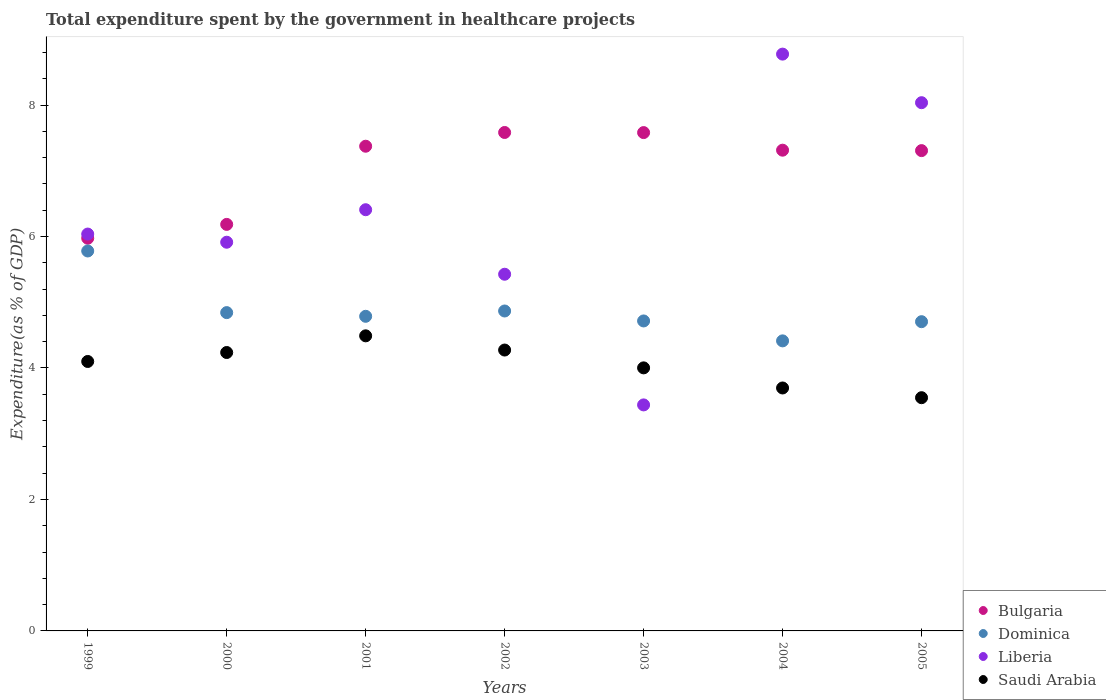How many different coloured dotlines are there?
Your response must be concise. 4. Is the number of dotlines equal to the number of legend labels?
Offer a terse response. Yes. What is the total expenditure spent by the government in healthcare projects in Bulgaria in 2004?
Your answer should be very brief. 7.31. Across all years, what is the maximum total expenditure spent by the government in healthcare projects in Dominica?
Give a very brief answer. 5.78. Across all years, what is the minimum total expenditure spent by the government in healthcare projects in Dominica?
Your response must be concise. 4.41. In which year was the total expenditure spent by the government in healthcare projects in Dominica maximum?
Offer a very short reply. 1999. In which year was the total expenditure spent by the government in healthcare projects in Liberia minimum?
Offer a terse response. 2003. What is the total total expenditure spent by the government in healthcare projects in Saudi Arabia in the graph?
Provide a succinct answer. 28.34. What is the difference between the total expenditure spent by the government in healthcare projects in Saudi Arabia in 2000 and that in 2005?
Give a very brief answer. 0.69. What is the difference between the total expenditure spent by the government in healthcare projects in Dominica in 2003 and the total expenditure spent by the government in healthcare projects in Bulgaria in 2005?
Provide a succinct answer. -2.59. What is the average total expenditure spent by the government in healthcare projects in Dominica per year?
Give a very brief answer. 4.87. In the year 2003, what is the difference between the total expenditure spent by the government in healthcare projects in Saudi Arabia and total expenditure spent by the government in healthcare projects in Dominica?
Your answer should be compact. -0.71. In how many years, is the total expenditure spent by the government in healthcare projects in Bulgaria greater than 1.2000000000000002 %?
Keep it short and to the point. 7. What is the ratio of the total expenditure spent by the government in healthcare projects in Liberia in 2000 to that in 2004?
Give a very brief answer. 0.67. Is the total expenditure spent by the government in healthcare projects in Dominica in 2001 less than that in 2004?
Provide a succinct answer. No. Is the difference between the total expenditure spent by the government in healthcare projects in Saudi Arabia in 1999 and 2003 greater than the difference between the total expenditure spent by the government in healthcare projects in Dominica in 1999 and 2003?
Give a very brief answer. No. What is the difference between the highest and the second highest total expenditure spent by the government in healthcare projects in Bulgaria?
Your response must be concise. 0. What is the difference between the highest and the lowest total expenditure spent by the government in healthcare projects in Liberia?
Your answer should be compact. 5.34. Is the sum of the total expenditure spent by the government in healthcare projects in Bulgaria in 2000 and 2005 greater than the maximum total expenditure spent by the government in healthcare projects in Dominica across all years?
Provide a short and direct response. Yes. Is it the case that in every year, the sum of the total expenditure spent by the government in healthcare projects in Saudi Arabia and total expenditure spent by the government in healthcare projects in Liberia  is greater than the sum of total expenditure spent by the government in healthcare projects in Bulgaria and total expenditure spent by the government in healthcare projects in Dominica?
Your response must be concise. No. Is it the case that in every year, the sum of the total expenditure spent by the government in healthcare projects in Liberia and total expenditure spent by the government in healthcare projects in Saudi Arabia  is greater than the total expenditure spent by the government in healthcare projects in Dominica?
Your answer should be very brief. Yes. Is the total expenditure spent by the government in healthcare projects in Saudi Arabia strictly greater than the total expenditure spent by the government in healthcare projects in Bulgaria over the years?
Provide a short and direct response. No. Is the total expenditure spent by the government in healthcare projects in Liberia strictly less than the total expenditure spent by the government in healthcare projects in Dominica over the years?
Offer a terse response. No. How many dotlines are there?
Provide a succinct answer. 4. Are the values on the major ticks of Y-axis written in scientific E-notation?
Your answer should be very brief. No. Does the graph contain any zero values?
Keep it short and to the point. No. Does the graph contain grids?
Offer a very short reply. No. Where does the legend appear in the graph?
Keep it short and to the point. Bottom right. How are the legend labels stacked?
Offer a terse response. Vertical. What is the title of the graph?
Give a very brief answer. Total expenditure spent by the government in healthcare projects. Does "Congo (Democratic)" appear as one of the legend labels in the graph?
Your response must be concise. No. What is the label or title of the Y-axis?
Provide a succinct answer. Expenditure(as % of GDP). What is the Expenditure(as % of GDP) of Bulgaria in 1999?
Provide a short and direct response. 5.97. What is the Expenditure(as % of GDP) of Dominica in 1999?
Provide a short and direct response. 5.78. What is the Expenditure(as % of GDP) of Liberia in 1999?
Provide a succinct answer. 6.04. What is the Expenditure(as % of GDP) in Saudi Arabia in 1999?
Offer a very short reply. 4.1. What is the Expenditure(as % of GDP) in Bulgaria in 2000?
Your answer should be very brief. 6.18. What is the Expenditure(as % of GDP) of Dominica in 2000?
Offer a terse response. 4.84. What is the Expenditure(as % of GDP) in Liberia in 2000?
Your answer should be compact. 5.91. What is the Expenditure(as % of GDP) of Saudi Arabia in 2000?
Your answer should be very brief. 4.24. What is the Expenditure(as % of GDP) in Bulgaria in 2001?
Your answer should be very brief. 7.37. What is the Expenditure(as % of GDP) in Dominica in 2001?
Give a very brief answer. 4.79. What is the Expenditure(as % of GDP) in Liberia in 2001?
Provide a short and direct response. 6.41. What is the Expenditure(as % of GDP) of Saudi Arabia in 2001?
Provide a succinct answer. 4.49. What is the Expenditure(as % of GDP) in Bulgaria in 2002?
Your response must be concise. 7.58. What is the Expenditure(as % of GDP) in Dominica in 2002?
Make the answer very short. 4.87. What is the Expenditure(as % of GDP) in Liberia in 2002?
Offer a terse response. 5.43. What is the Expenditure(as % of GDP) in Saudi Arabia in 2002?
Offer a very short reply. 4.27. What is the Expenditure(as % of GDP) in Bulgaria in 2003?
Provide a short and direct response. 7.58. What is the Expenditure(as % of GDP) in Dominica in 2003?
Your answer should be very brief. 4.72. What is the Expenditure(as % of GDP) in Liberia in 2003?
Give a very brief answer. 3.44. What is the Expenditure(as % of GDP) of Saudi Arabia in 2003?
Provide a succinct answer. 4. What is the Expenditure(as % of GDP) of Bulgaria in 2004?
Provide a short and direct response. 7.31. What is the Expenditure(as % of GDP) in Dominica in 2004?
Offer a terse response. 4.41. What is the Expenditure(as % of GDP) of Liberia in 2004?
Offer a very short reply. 8.77. What is the Expenditure(as % of GDP) in Saudi Arabia in 2004?
Provide a short and direct response. 3.7. What is the Expenditure(as % of GDP) in Bulgaria in 2005?
Offer a very short reply. 7.31. What is the Expenditure(as % of GDP) of Dominica in 2005?
Your answer should be compact. 4.7. What is the Expenditure(as % of GDP) in Liberia in 2005?
Your response must be concise. 8.04. What is the Expenditure(as % of GDP) in Saudi Arabia in 2005?
Provide a short and direct response. 3.55. Across all years, what is the maximum Expenditure(as % of GDP) in Bulgaria?
Ensure brevity in your answer.  7.58. Across all years, what is the maximum Expenditure(as % of GDP) of Dominica?
Provide a short and direct response. 5.78. Across all years, what is the maximum Expenditure(as % of GDP) of Liberia?
Your response must be concise. 8.77. Across all years, what is the maximum Expenditure(as % of GDP) in Saudi Arabia?
Offer a terse response. 4.49. Across all years, what is the minimum Expenditure(as % of GDP) of Bulgaria?
Offer a very short reply. 5.97. Across all years, what is the minimum Expenditure(as % of GDP) in Dominica?
Your answer should be very brief. 4.41. Across all years, what is the minimum Expenditure(as % of GDP) in Liberia?
Provide a short and direct response. 3.44. Across all years, what is the minimum Expenditure(as % of GDP) of Saudi Arabia?
Make the answer very short. 3.55. What is the total Expenditure(as % of GDP) of Bulgaria in the graph?
Give a very brief answer. 49.32. What is the total Expenditure(as % of GDP) of Dominica in the graph?
Offer a terse response. 34.11. What is the total Expenditure(as % of GDP) in Liberia in the graph?
Your answer should be very brief. 44.03. What is the total Expenditure(as % of GDP) of Saudi Arabia in the graph?
Keep it short and to the point. 28.34. What is the difference between the Expenditure(as % of GDP) in Bulgaria in 1999 and that in 2000?
Give a very brief answer. -0.21. What is the difference between the Expenditure(as % of GDP) of Dominica in 1999 and that in 2000?
Offer a terse response. 0.94. What is the difference between the Expenditure(as % of GDP) in Liberia in 1999 and that in 2000?
Your response must be concise. 0.12. What is the difference between the Expenditure(as % of GDP) of Saudi Arabia in 1999 and that in 2000?
Provide a short and direct response. -0.14. What is the difference between the Expenditure(as % of GDP) of Bulgaria in 1999 and that in 2001?
Give a very brief answer. -1.4. What is the difference between the Expenditure(as % of GDP) in Liberia in 1999 and that in 2001?
Offer a terse response. -0.37. What is the difference between the Expenditure(as % of GDP) in Saudi Arabia in 1999 and that in 2001?
Provide a short and direct response. -0.39. What is the difference between the Expenditure(as % of GDP) in Bulgaria in 1999 and that in 2002?
Offer a very short reply. -1.61. What is the difference between the Expenditure(as % of GDP) of Dominica in 1999 and that in 2002?
Give a very brief answer. 0.91. What is the difference between the Expenditure(as % of GDP) in Liberia in 1999 and that in 2002?
Offer a very short reply. 0.61. What is the difference between the Expenditure(as % of GDP) of Saudi Arabia in 1999 and that in 2002?
Give a very brief answer. -0.17. What is the difference between the Expenditure(as % of GDP) in Bulgaria in 1999 and that in 2003?
Offer a terse response. -1.61. What is the difference between the Expenditure(as % of GDP) of Dominica in 1999 and that in 2003?
Your response must be concise. 1.06. What is the difference between the Expenditure(as % of GDP) of Liberia in 1999 and that in 2003?
Offer a terse response. 2.6. What is the difference between the Expenditure(as % of GDP) in Saudi Arabia in 1999 and that in 2003?
Your answer should be compact. 0.1. What is the difference between the Expenditure(as % of GDP) of Bulgaria in 1999 and that in 2004?
Your answer should be very brief. -1.34. What is the difference between the Expenditure(as % of GDP) of Dominica in 1999 and that in 2004?
Your answer should be compact. 1.37. What is the difference between the Expenditure(as % of GDP) of Liberia in 1999 and that in 2004?
Give a very brief answer. -2.74. What is the difference between the Expenditure(as % of GDP) of Saudi Arabia in 1999 and that in 2004?
Make the answer very short. 0.4. What is the difference between the Expenditure(as % of GDP) of Bulgaria in 1999 and that in 2005?
Ensure brevity in your answer.  -1.33. What is the difference between the Expenditure(as % of GDP) in Dominica in 1999 and that in 2005?
Provide a short and direct response. 1.08. What is the difference between the Expenditure(as % of GDP) in Liberia in 1999 and that in 2005?
Keep it short and to the point. -2. What is the difference between the Expenditure(as % of GDP) of Saudi Arabia in 1999 and that in 2005?
Your response must be concise. 0.55. What is the difference between the Expenditure(as % of GDP) in Bulgaria in 2000 and that in 2001?
Ensure brevity in your answer.  -1.19. What is the difference between the Expenditure(as % of GDP) in Dominica in 2000 and that in 2001?
Provide a short and direct response. 0.06. What is the difference between the Expenditure(as % of GDP) in Liberia in 2000 and that in 2001?
Provide a short and direct response. -0.49. What is the difference between the Expenditure(as % of GDP) in Saudi Arabia in 2000 and that in 2001?
Give a very brief answer. -0.25. What is the difference between the Expenditure(as % of GDP) in Bulgaria in 2000 and that in 2002?
Offer a terse response. -1.4. What is the difference between the Expenditure(as % of GDP) in Dominica in 2000 and that in 2002?
Offer a terse response. -0.02. What is the difference between the Expenditure(as % of GDP) of Liberia in 2000 and that in 2002?
Offer a very short reply. 0.49. What is the difference between the Expenditure(as % of GDP) in Saudi Arabia in 2000 and that in 2002?
Your response must be concise. -0.04. What is the difference between the Expenditure(as % of GDP) in Bulgaria in 2000 and that in 2003?
Your answer should be compact. -1.4. What is the difference between the Expenditure(as % of GDP) of Dominica in 2000 and that in 2003?
Keep it short and to the point. 0.13. What is the difference between the Expenditure(as % of GDP) of Liberia in 2000 and that in 2003?
Your answer should be very brief. 2.47. What is the difference between the Expenditure(as % of GDP) in Saudi Arabia in 2000 and that in 2003?
Give a very brief answer. 0.23. What is the difference between the Expenditure(as % of GDP) in Bulgaria in 2000 and that in 2004?
Give a very brief answer. -1.13. What is the difference between the Expenditure(as % of GDP) in Dominica in 2000 and that in 2004?
Your answer should be very brief. 0.43. What is the difference between the Expenditure(as % of GDP) of Liberia in 2000 and that in 2004?
Make the answer very short. -2.86. What is the difference between the Expenditure(as % of GDP) in Saudi Arabia in 2000 and that in 2004?
Give a very brief answer. 0.54. What is the difference between the Expenditure(as % of GDP) of Bulgaria in 2000 and that in 2005?
Provide a succinct answer. -1.12. What is the difference between the Expenditure(as % of GDP) in Dominica in 2000 and that in 2005?
Your answer should be very brief. 0.14. What is the difference between the Expenditure(as % of GDP) in Liberia in 2000 and that in 2005?
Your response must be concise. -2.12. What is the difference between the Expenditure(as % of GDP) of Saudi Arabia in 2000 and that in 2005?
Offer a terse response. 0.69. What is the difference between the Expenditure(as % of GDP) in Bulgaria in 2001 and that in 2002?
Make the answer very short. -0.21. What is the difference between the Expenditure(as % of GDP) in Dominica in 2001 and that in 2002?
Give a very brief answer. -0.08. What is the difference between the Expenditure(as % of GDP) of Liberia in 2001 and that in 2002?
Your response must be concise. 0.98. What is the difference between the Expenditure(as % of GDP) in Saudi Arabia in 2001 and that in 2002?
Your response must be concise. 0.22. What is the difference between the Expenditure(as % of GDP) in Bulgaria in 2001 and that in 2003?
Your response must be concise. -0.21. What is the difference between the Expenditure(as % of GDP) of Dominica in 2001 and that in 2003?
Offer a very short reply. 0.07. What is the difference between the Expenditure(as % of GDP) of Liberia in 2001 and that in 2003?
Provide a short and direct response. 2.97. What is the difference between the Expenditure(as % of GDP) in Saudi Arabia in 2001 and that in 2003?
Offer a terse response. 0.49. What is the difference between the Expenditure(as % of GDP) in Bulgaria in 2001 and that in 2004?
Keep it short and to the point. 0.06. What is the difference between the Expenditure(as % of GDP) in Dominica in 2001 and that in 2004?
Offer a very short reply. 0.37. What is the difference between the Expenditure(as % of GDP) in Liberia in 2001 and that in 2004?
Your answer should be compact. -2.37. What is the difference between the Expenditure(as % of GDP) in Saudi Arabia in 2001 and that in 2004?
Offer a very short reply. 0.79. What is the difference between the Expenditure(as % of GDP) of Bulgaria in 2001 and that in 2005?
Make the answer very short. 0.07. What is the difference between the Expenditure(as % of GDP) in Dominica in 2001 and that in 2005?
Make the answer very short. 0.08. What is the difference between the Expenditure(as % of GDP) in Liberia in 2001 and that in 2005?
Provide a short and direct response. -1.63. What is the difference between the Expenditure(as % of GDP) in Saudi Arabia in 2001 and that in 2005?
Your response must be concise. 0.94. What is the difference between the Expenditure(as % of GDP) in Bulgaria in 2002 and that in 2003?
Give a very brief answer. 0. What is the difference between the Expenditure(as % of GDP) of Dominica in 2002 and that in 2003?
Provide a short and direct response. 0.15. What is the difference between the Expenditure(as % of GDP) of Liberia in 2002 and that in 2003?
Offer a terse response. 1.99. What is the difference between the Expenditure(as % of GDP) in Saudi Arabia in 2002 and that in 2003?
Your response must be concise. 0.27. What is the difference between the Expenditure(as % of GDP) in Bulgaria in 2002 and that in 2004?
Your response must be concise. 0.27. What is the difference between the Expenditure(as % of GDP) in Dominica in 2002 and that in 2004?
Your answer should be compact. 0.45. What is the difference between the Expenditure(as % of GDP) in Liberia in 2002 and that in 2004?
Provide a short and direct response. -3.35. What is the difference between the Expenditure(as % of GDP) in Saudi Arabia in 2002 and that in 2004?
Your answer should be very brief. 0.58. What is the difference between the Expenditure(as % of GDP) of Bulgaria in 2002 and that in 2005?
Provide a succinct answer. 0.28. What is the difference between the Expenditure(as % of GDP) of Dominica in 2002 and that in 2005?
Ensure brevity in your answer.  0.16. What is the difference between the Expenditure(as % of GDP) of Liberia in 2002 and that in 2005?
Provide a short and direct response. -2.61. What is the difference between the Expenditure(as % of GDP) in Saudi Arabia in 2002 and that in 2005?
Offer a terse response. 0.72. What is the difference between the Expenditure(as % of GDP) of Bulgaria in 2003 and that in 2004?
Keep it short and to the point. 0.27. What is the difference between the Expenditure(as % of GDP) in Dominica in 2003 and that in 2004?
Your response must be concise. 0.3. What is the difference between the Expenditure(as % of GDP) in Liberia in 2003 and that in 2004?
Offer a terse response. -5.34. What is the difference between the Expenditure(as % of GDP) in Saudi Arabia in 2003 and that in 2004?
Provide a short and direct response. 0.31. What is the difference between the Expenditure(as % of GDP) of Bulgaria in 2003 and that in 2005?
Your answer should be very brief. 0.27. What is the difference between the Expenditure(as % of GDP) in Dominica in 2003 and that in 2005?
Keep it short and to the point. 0.01. What is the difference between the Expenditure(as % of GDP) in Liberia in 2003 and that in 2005?
Provide a short and direct response. -4.6. What is the difference between the Expenditure(as % of GDP) of Saudi Arabia in 2003 and that in 2005?
Give a very brief answer. 0.45. What is the difference between the Expenditure(as % of GDP) of Bulgaria in 2004 and that in 2005?
Keep it short and to the point. 0.01. What is the difference between the Expenditure(as % of GDP) of Dominica in 2004 and that in 2005?
Your answer should be very brief. -0.29. What is the difference between the Expenditure(as % of GDP) in Liberia in 2004 and that in 2005?
Make the answer very short. 0.74. What is the difference between the Expenditure(as % of GDP) of Saudi Arabia in 2004 and that in 2005?
Ensure brevity in your answer.  0.15. What is the difference between the Expenditure(as % of GDP) of Bulgaria in 1999 and the Expenditure(as % of GDP) of Dominica in 2000?
Offer a terse response. 1.13. What is the difference between the Expenditure(as % of GDP) of Bulgaria in 1999 and the Expenditure(as % of GDP) of Liberia in 2000?
Your response must be concise. 0.06. What is the difference between the Expenditure(as % of GDP) of Bulgaria in 1999 and the Expenditure(as % of GDP) of Saudi Arabia in 2000?
Ensure brevity in your answer.  1.74. What is the difference between the Expenditure(as % of GDP) in Dominica in 1999 and the Expenditure(as % of GDP) in Liberia in 2000?
Offer a very short reply. -0.13. What is the difference between the Expenditure(as % of GDP) of Dominica in 1999 and the Expenditure(as % of GDP) of Saudi Arabia in 2000?
Make the answer very short. 1.54. What is the difference between the Expenditure(as % of GDP) of Liberia in 1999 and the Expenditure(as % of GDP) of Saudi Arabia in 2000?
Ensure brevity in your answer.  1.8. What is the difference between the Expenditure(as % of GDP) of Bulgaria in 1999 and the Expenditure(as % of GDP) of Dominica in 2001?
Make the answer very short. 1.19. What is the difference between the Expenditure(as % of GDP) of Bulgaria in 1999 and the Expenditure(as % of GDP) of Liberia in 2001?
Provide a short and direct response. -0.43. What is the difference between the Expenditure(as % of GDP) of Bulgaria in 1999 and the Expenditure(as % of GDP) of Saudi Arabia in 2001?
Give a very brief answer. 1.48. What is the difference between the Expenditure(as % of GDP) of Dominica in 1999 and the Expenditure(as % of GDP) of Liberia in 2001?
Provide a succinct answer. -0.63. What is the difference between the Expenditure(as % of GDP) of Dominica in 1999 and the Expenditure(as % of GDP) of Saudi Arabia in 2001?
Offer a very short reply. 1.29. What is the difference between the Expenditure(as % of GDP) in Liberia in 1999 and the Expenditure(as % of GDP) in Saudi Arabia in 2001?
Your response must be concise. 1.55. What is the difference between the Expenditure(as % of GDP) in Bulgaria in 1999 and the Expenditure(as % of GDP) in Dominica in 2002?
Your answer should be compact. 1.11. What is the difference between the Expenditure(as % of GDP) of Bulgaria in 1999 and the Expenditure(as % of GDP) of Liberia in 2002?
Provide a succinct answer. 0.55. What is the difference between the Expenditure(as % of GDP) of Bulgaria in 1999 and the Expenditure(as % of GDP) of Saudi Arabia in 2002?
Offer a very short reply. 1.7. What is the difference between the Expenditure(as % of GDP) of Dominica in 1999 and the Expenditure(as % of GDP) of Liberia in 2002?
Offer a terse response. 0.35. What is the difference between the Expenditure(as % of GDP) in Dominica in 1999 and the Expenditure(as % of GDP) in Saudi Arabia in 2002?
Ensure brevity in your answer.  1.51. What is the difference between the Expenditure(as % of GDP) in Liberia in 1999 and the Expenditure(as % of GDP) in Saudi Arabia in 2002?
Make the answer very short. 1.76. What is the difference between the Expenditure(as % of GDP) in Bulgaria in 1999 and the Expenditure(as % of GDP) in Dominica in 2003?
Keep it short and to the point. 1.26. What is the difference between the Expenditure(as % of GDP) in Bulgaria in 1999 and the Expenditure(as % of GDP) in Liberia in 2003?
Provide a succinct answer. 2.54. What is the difference between the Expenditure(as % of GDP) of Bulgaria in 1999 and the Expenditure(as % of GDP) of Saudi Arabia in 2003?
Offer a terse response. 1.97. What is the difference between the Expenditure(as % of GDP) in Dominica in 1999 and the Expenditure(as % of GDP) in Liberia in 2003?
Offer a terse response. 2.34. What is the difference between the Expenditure(as % of GDP) of Dominica in 1999 and the Expenditure(as % of GDP) of Saudi Arabia in 2003?
Ensure brevity in your answer.  1.78. What is the difference between the Expenditure(as % of GDP) of Liberia in 1999 and the Expenditure(as % of GDP) of Saudi Arabia in 2003?
Keep it short and to the point. 2.04. What is the difference between the Expenditure(as % of GDP) in Bulgaria in 1999 and the Expenditure(as % of GDP) in Dominica in 2004?
Offer a very short reply. 1.56. What is the difference between the Expenditure(as % of GDP) in Bulgaria in 1999 and the Expenditure(as % of GDP) in Liberia in 2004?
Your answer should be very brief. -2.8. What is the difference between the Expenditure(as % of GDP) of Bulgaria in 1999 and the Expenditure(as % of GDP) of Saudi Arabia in 2004?
Your response must be concise. 2.28. What is the difference between the Expenditure(as % of GDP) of Dominica in 1999 and the Expenditure(as % of GDP) of Liberia in 2004?
Give a very brief answer. -2.99. What is the difference between the Expenditure(as % of GDP) of Dominica in 1999 and the Expenditure(as % of GDP) of Saudi Arabia in 2004?
Offer a terse response. 2.08. What is the difference between the Expenditure(as % of GDP) in Liberia in 1999 and the Expenditure(as % of GDP) in Saudi Arabia in 2004?
Your answer should be very brief. 2.34. What is the difference between the Expenditure(as % of GDP) of Bulgaria in 1999 and the Expenditure(as % of GDP) of Dominica in 2005?
Provide a short and direct response. 1.27. What is the difference between the Expenditure(as % of GDP) in Bulgaria in 1999 and the Expenditure(as % of GDP) in Liberia in 2005?
Give a very brief answer. -2.06. What is the difference between the Expenditure(as % of GDP) of Bulgaria in 1999 and the Expenditure(as % of GDP) of Saudi Arabia in 2005?
Your answer should be compact. 2.43. What is the difference between the Expenditure(as % of GDP) in Dominica in 1999 and the Expenditure(as % of GDP) in Liberia in 2005?
Your answer should be very brief. -2.26. What is the difference between the Expenditure(as % of GDP) of Dominica in 1999 and the Expenditure(as % of GDP) of Saudi Arabia in 2005?
Provide a short and direct response. 2.23. What is the difference between the Expenditure(as % of GDP) of Liberia in 1999 and the Expenditure(as % of GDP) of Saudi Arabia in 2005?
Your answer should be very brief. 2.49. What is the difference between the Expenditure(as % of GDP) of Bulgaria in 2000 and the Expenditure(as % of GDP) of Dominica in 2001?
Your response must be concise. 1.4. What is the difference between the Expenditure(as % of GDP) of Bulgaria in 2000 and the Expenditure(as % of GDP) of Liberia in 2001?
Your answer should be compact. -0.22. What is the difference between the Expenditure(as % of GDP) of Bulgaria in 2000 and the Expenditure(as % of GDP) of Saudi Arabia in 2001?
Provide a short and direct response. 1.7. What is the difference between the Expenditure(as % of GDP) in Dominica in 2000 and the Expenditure(as % of GDP) in Liberia in 2001?
Offer a very short reply. -1.57. What is the difference between the Expenditure(as % of GDP) in Dominica in 2000 and the Expenditure(as % of GDP) in Saudi Arabia in 2001?
Offer a very short reply. 0.35. What is the difference between the Expenditure(as % of GDP) in Liberia in 2000 and the Expenditure(as % of GDP) in Saudi Arabia in 2001?
Your response must be concise. 1.42. What is the difference between the Expenditure(as % of GDP) in Bulgaria in 2000 and the Expenditure(as % of GDP) in Dominica in 2002?
Your response must be concise. 1.32. What is the difference between the Expenditure(as % of GDP) of Bulgaria in 2000 and the Expenditure(as % of GDP) of Liberia in 2002?
Make the answer very short. 0.76. What is the difference between the Expenditure(as % of GDP) of Bulgaria in 2000 and the Expenditure(as % of GDP) of Saudi Arabia in 2002?
Give a very brief answer. 1.91. What is the difference between the Expenditure(as % of GDP) in Dominica in 2000 and the Expenditure(as % of GDP) in Liberia in 2002?
Give a very brief answer. -0.58. What is the difference between the Expenditure(as % of GDP) of Dominica in 2000 and the Expenditure(as % of GDP) of Saudi Arabia in 2002?
Provide a succinct answer. 0.57. What is the difference between the Expenditure(as % of GDP) in Liberia in 2000 and the Expenditure(as % of GDP) in Saudi Arabia in 2002?
Offer a very short reply. 1.64. What is the difference between the Expenditure(as % of GDP) of Bulgaria in 2000 and the Expenditure(as % of GDP) of Dominica in 2003?
Provide a succinct answer. 1.47. What is the difference between the Expenditure(as % of GDP) of Bulgaria in 2000 and the Expenditure(as % of GDP) of Liberia in 2003?
Provide a succinct answer. 2.75. What is the difference between the Expenditure(as % of GDP) of Bulgaria in 2000 and the Expenditure(as % of GDP) of Saudi Arabia in 2003?
Your answer should be compact. 2.18. What is the difference between the Expenditure(as % of GDP) of Dominica in 2000 and the Expenditure(as % of GDP) of Liberia in 2003?
Keep it short and to the point. 1.4. What is the difference between the Expenditure(as % of GDP) in Dominica in 2000 and the Expenditure(as % of GDP) in Saudi Arabia in 2003?
Your answer should be compact. 0.84. What is the difference between the Expenditure(as % of GDP) in Liberia in 2000 and the Expenditure(as % of GDP) in Saudi Arabia in 2003?
Make the answer very short. 1.91. What is the difference between the Expenditure(as % of GDP) of Bulgaria in 2000 and the Expenditure(as % of GDP) of Dominica in 2004?
Offer a very short reply. 1.77. What is the difference between the Expenditure(as % of GDP) of Bulgaria in 2000 and the Expenditure(as % of GDP) of Liberia in 2004?
Provide a succinct answer. -2.59. What is the difference between the Expenditure(as % of GDP) in Bulgaria in 2000 and the Expenditure(as % of GDP) in Saudi Arabia in 2004?
Offer a very short reply. 2.49. What is the difference between the Expenditure(as % of GDP) of Dominica in 2000 and the Expenditure(as % of GDP) of Liberia in 2004?
Provide a succinct answer. -3.93. What is the difference between the Expenditure(as % of GDP) in Dominica in 2000 and the Expenditure(as % of GDP) in Saudi Arabia in 2004?
Offer a very short reply. 1.15. What is the difference between the Expenditure(as % of GDP) of Liberia in 2000 and the Expenditure(as % of GDP) of Saudi Arabia in 2004?
Offer a terse response. 2.22. What is the difference between the Expenditure(as % of GDP) of Bulgaria in 2000 and the Expenditure(as % of GDP) of Dominica in 2005?
Provide a succinct answer. 1.48. What is the difference between the Expenditure(as % of GDP) in Bulgaria in 2000 and the Expenditure(as % of GDP) in Liberia in 2005?
Provide a succinct answer. -1.85. What is the difference between the Expenditure(as % of GDP) in Bulgaria in 2000 and the Expenditure(as % of GDP) in Saudi Arabia in 2005?
Give a very brief answer. 2.64. What is the difference between the Expenditure(as % of GDP) of Dominica in 2000 and the Expenditure(as % of GDP) of Liberia in 2005?
Provide a short and direct response. -3.19. What is the difference between the Expenditure(as % of GDP) in Dominica in 2000 and the Expenditure(as % of GDP) in Saudi Arabia in 2005?
Offer a terse response. 1.29. What is the difference between the Expenditure(as % of GDP) of Liberia in 2000 and the Expenditure(as % of GDP) of Saudi Arabia in 2005?
Your answer should be compact. 2.37. What is the difference between the Expenditure(as % of GDP) in Bulgaria in 2001 and the Expenditure(as % of GDP) in Dominica in 2002?
Your response must be concise. 2.51. What is the difference between the Expenditure(as % of GDP) of Bulgaria in 2001 and the Expenditure(as % of GDP) of Liberia in 2002?
Offer a terse response. 1.95. What is the difference between the Expenditure(as % of GDP) of Bulgaria in 2001 and the Expenditure(as % of GDP) of Saudi Arabia in 2002?
Offer a terse response. 3.1. What is the difference between the Expenditure(as % of GDP) in Dominica in 2001 and the Expenditure(as % of GDP) in Liberia in 2002?
Provide a succinct answer. -0.64. What is the difference between the Expenditure(as % of GDP) in Dominica in 2001 and the Expenditure(as % of GDP) in Saudi Arabia in 2002?
Give a very brief answer. 0.51. What is the difference between the Expenditure(as % of GDP) of Liberia in 2001 and the Expenditure(as % of GDP) of Saudi Arabia in 2002?
Your response must be concise. 2.13. What is the difference between the Expenditure(as % of GDP) in Bulgaria in 2001 and the Expenditure(as % of GDP) in Dominica in 2003?
Your response must be concise. 2.66. What is the difference between the Expenditure(as % of GDP) of Bulgaria in 2001 and the Expenditure(as % of GDP) of Liberia in 2003?
Keep it short and to the point. 3.94. What is the difference between the Expenditure(as % of GDP) of Bulgaria in 2001 and the Expenditure(as % of GDP) of Saudi Arabia in 2003?
Offer a terse response. 3.37. What is the difference between the Expenditure(as % of GDP) in Dominica in 2001 and the Expenditure(as % of GDP) in Liberia in 2003?
Offer a very short reply. 1.35. What is the difference between the Expenditure(as % of GDP) of Dominica in 2001 and the Expenditure(as % of GDP) of Saudi Arabia in 2003?
Your response must be concise. 0.78. What is the difference between the Expenditure(as % of GDP) of Liberia in 2001 and the Expenditure(as % of GDP) of Saudi Arabia in 2003?
Offer a very short reply. 2.41. What is the difference between the Expenditure(as % of GDP) of Bulgaria in 2001 and the Expenditure(as % of GDP) of Dominica in 2004?
Make the answer very short. 2.96. What is the difference between the Expenditure(as % of GDP) of Bulgaria in 2001 and the Expenditure(as % of GDP) of Liberia in 2004?
Offer a terse response. -1.4. What is the difference between the Expenditure(as % of GDP) of Bulgaria in 2001 and the Expenditure(as % of GDP) of Saudi Arabia in 2004?
Keep it short and to the point. 3.68. What is the difference between the Expenditure(as % of GDP) of Dominica in 2001 and the Expenditure(as % of GDP) of Liberia in 2004?
Your answer should be very brief. -3.99. What is the difference between the Expenditure(as % of GDP) of Dominica in 2001 and the Expenditure(as % of GDP) of Saudi Arabia in 2004?
Your answer should be compact. 1.09. What is the difference between the Expenditure(as % of GDP) of Liberia in 2001 and the Expenditure(as % of GDP) of Saudi Arabia in 2004?
Your answer should be very brief. 2.71. What is the difference between the Expenditure(as % of GDP) in Bulgaria in 2001 and the Expenditure(as % of GDP) in Dominica in 2005?
Keep it short and to the point. 2.67. What is the difference between the Expenditure(as % of GDP) of Bulgaria in 2001 and the Expenditure(as % of GDP) of Liberia in 2005?
Make the answer very short. -0.66. What is the difference between the Expenditure(as % of GDP) of Bulgaria in 2001 and the Expenditure(as % of GDP) of Saudi Arabia in 2005?
Offer a terse response. 3.83. What is the difference between the Expenditure(as % of GDP) of Dominica in 2001 and the Expenditure(as % of GDP) of Liberia in 2005?
Give a very brief answer. -3.25. What is the difference between the Expenditure(as % of GDP) in Dominica in 2001 and the Expenditure(as % of GDP) in Saudi Arabia in 2005?
Provide a short and direct response. 1.24. What is the difference between the Expenditure(as % of GDP) of Liberia in 2001 and the Expenditure(as % of GDP) of Saudi Arabia in 2005?
Make the answer very short. 2.86. What is the difference between the Expenditure(as % of GDP) of Bulgaria in 2002 and the Expenditure(as % of GDP) of Dominica in 2003?
Provide a succinct answer. 2.87. What is the difference between the Expenditure(as % of GDP) in Bulgaria in 2002 and the Expenditure(as % of GDP) in Liberia in 2003?
Your answer should be very brief. 4.14. What is the difference between the Expenditure(as % of GDP) in Bulgaria in 2002 and the Expenditure(as % of GDP) in Saudi Arabia in 2003?
Your answer should be compact. 3.58. What is the difference between the Expenditure(as % of GDP) of Dominica in 2002 and the Expenditure(as % of GDP) of Liberia in 2003?
Your response must be concise. 1.43. What is the difference between the Expenditure(as % of GDP) in Dominica in 2002 and the Expenditure(as % of GDP) in Saudi Arabia in 2003?
Keep it short and to the point. 0.87. What is the difference between the Expenditure(as % of GDP) of Liberia in 2002 and the Expenditure(as % of GDP) of Saudi Arabia in 2003?
Offer a very short reply. 1.42. What is the difference between the Expenditure(as % of GDP) of Bulgaria in 2002 and the Expenditure(as % of GDP) of Dominica in 2004?
Offer a very short reply. 3.17. What is the difference between the Expenditure(as % of GDP) in Bulgaria in 2002 and the Expenditure(as % of GDP) in Liberia in 2004?
Offer a very short reply. -1.19. What is the difference between the Expenditure(as % of GDP) in Bulgaria in 2002 and the Expenditure(as % of GDP) in Saudi Arabia in 2004?
Offer a very short reply. 3.89. What is the difference between the Expenditure(as % of GDP) of Dominica in 2002 and the Expenditure(as % of GDP) of Liberia in 2004?
Make the answer very short. -3.91. What is the difference between the Expenditure(as % of GDP) of Dominica in 2002 and the Expenditure(as % of GDP) of Saudi Arabia in 2004?
Give a very brief answer. 1.17. What is the difference between the Expenditure(as % of GDP) of Liberia in 2002 and the Expenditure(as % of GDP) of Saudi Arabia in 2004?
Your response must be concise. 1.73. What is the difference between the Expenditure(as % of GDP) of Bulgaria in 2002 and the Expenditure(as % of GDP) of Dominica in 2005?
Your answer should be compact. 2.88. What is the difference between the Expenditure(as % of GDP) of Bulgaria in 2002 and the Expenditure(as % of GDP) of Liberia in 2005?
Your answer should be compact. -0.45. What is the difference between the Expenditure(as % of GDP) in Bulgaria in 2002 and the Expenditure(as % of GDP) in Saudi Arabia in 2005?
Make the answer very short. 4.03. What is the difference between the Expenditure(as % of GDP) in Dominica in 2002 and the Expenditure(as % of GDP) in Liberia in 2005?
Make the answer very short. -3.17. What is the difference between the Expenditure(as % of GDP) in Dominica in 2002 and the Expenditure(as % of GDP) in Saudi Arabia in 2005?
Keep it short and to the point. 1.32. What is the difference between the Expenditure(as % of GDP) of Liberia in 2002 and the Expenditure(as % of GDP) of Saudi Arabia in 2005?
Make the answer very short. 1.88. What is the difference between the Expenditure(as % of GDP) of Bulgaria in 2003 and the Expenditure(as % of GDP) of Dominica in 2004?
Provide a short and direct response. 3.17. What is the difference between the Expenditure(as % of GDP) of Bulgaria in 2003 and the Expenditure(as % of GDP) of Liberia in 2004?
Make the answer very short. -1.19. What is the difference between the Expenditure(as % of GDP) in Bulgaria in 2003 and the Expenditure(as % of GDP) in Saudi Arabia in 2004?
Keep it short and to the point. 3.89. What is the difference between the Expenditure(as % of GDP) of Dominica in 2003 and the Expenditure(as % of GDP) of Liberia in 2004?
Provide a short and direct response. -4.06. What is the difference between the Expenditure(as % of GDP) in Dominica in 2003 and the Expenditure(as % of GDP) in Saudi Arabia in 2004?
Give a very brief answer. 1.02. What is the difference between the Expenditure(as % of GDP) of Liberia in 2003 and the Expenditure(as % of GDP) of Saudi Arabia in 2004?
Your answer should be very brief. -0.26. What is the difference between the Expenditure(as % of GDP) in Bulgaria in 2003 and the Expenditure(as % of GDP) in Dominica in 2005?
Your answer should be compact. 2.88. What is the difference between the Expenditure(as % of GDP) of Bulgaria in 2003 and the Expenditure(as % of GDP) of Liberia in 2005?
Give a very brief answer. -0.45. What is the difference between the Expenditure(as % of GDP) in Bulgaria in 2003 and the Expenditure(as % of GDP) in Saudi Arabia in 2005?
Give a very brief answer. 4.03. What is the difference between the Expenditure(as % of GDP) of Dominica in 2003 and the Expenditure(as % of GDP) of Liberia in 2005?
Your answer should be very brief. -3.32. What is the difference between the Expenditure(as % of GDP) in Dominica in 2003 and the Expenditure(as % of GDP) in Saudi Arabia in 2005?
Keep it short and to the point. 1.17. What is the difference between the Expenditure(as % of GDP) in Liberia in 2003 and the Expenditure(as % of GDP) in Saudi Arabia in 2005?
Keep it short and to the point. -0.11. What is the difference between the Expenditure(as % of GDP) of Bulgaria in 2004 and the Expenditure(as % of GDP) of Dominica in 2005?
Your answer should be very brief. 2.61. What is the difference between the Expenditure(as % of GDP) of Bulgaria in 2004 and the Expenditure(as % of GDP) of Liberia in 2005?
Offer a very short reply. -0.72. What is the difference between the Expenditure(as % of GDP) of Bulgaria in 2004 and the Expenditure(as % of GDP) of Saudi Arabia in 2005?
Offer a terse response. 3.77. What is the difference between the Expenditure(as % of GDP) in Dominica in 2004 and the Expenditure(as % of GDP) in Liberia in 2005?
Ensure brevity in your answer.  -3.62. What is the difference between the Expenditure(as % of GDP) in Dominica in 2004 and the Expenditure(as % of GDP) in Saudi Arabia in 2005?
Your answer should be very brief. 0.86. What is the difference between the Expenditure(as % of GDP) of Liberia in 2004 and the Expenditure(as % of GDP) of Saudi Arabia in 2005?
Provide a short and direct response. 5.23. What is the average Expenditure(as % of GDP) in Bulgaria per year?
Provide a short and direct response. 7.05. What is the average Expenditure(as % of GDP) in Dominica per year?
Provide a short and direct response. 4.87. What is the average Expenditure(as % of GDP) in Liberia per year?
Your response must be concise. 6.29. What is the average Expenditure(as % of GDP) of Saudi Arabia per year?
Your response must be concise. 4.05. In the year 1999, what is the difference between the Expenditure(as % of GDP) in Bulgaria and Expenditure(as % of GDP) in Dominica?
Keep it short and to the point. 0.19. In the year 1999, what is the difference between the Expenditure(as % of GDP) of Bulgaria and Expenditure(as % of GDP) of Liberia?
Your answer should be very brief. -0.06. In the year 1999, what is the difference between the Expenditure(as % of GDP) in Bulgaria and Expenditure(as % of GDP) in Saudi Arabia?
Provide a succinct answer. 1.87. In the year 1999, what is the difference between the Expenditure(as % of GDP) of Dominica and Expenditure(as % of GDP) of Liberia?
Your answer should be very brief. -0.26. In the year 1999, what is the difference between the Expenditure(as % of GDP) in Dominica and Expenditure(as % of GDP) in Saudi Arabia?
Your answer should be compact. 1.68. In the year 1999, what is the difference between the Expenditure(as % of GDP) in Liberia and Expenditure(as % of GDP) in Saudi Arabia?
Your answer should be compact. 1.94. In the year 2000, what is the difference between the Expenditure(as % of GDP) in Bulgaria and Expenditure(as % of GDP) in Dominica?
Make the answer very short. 1.34. In the year 2000, what is the difference between the Expenditure(as % of GDP) of Bulgaria and Expenditure(as % of GDP) of Liberia?
Your answer should be compact. 0.27. In the year 2000, what is the difference between the Expenditure(as % of GDP) in Bulgaria and Expenditure(as % of GDP) in Saudi Arabia?
Offer a terse response. 1.95. In the year 2000, what is the difference between the Expenditure(as % of GDP) of Dominica and Expenditure(as % of GDP) of Liberia?
Ensure brevity in your answer.  -1.07. In the year 2000, what is the difference between the Expenditure(as % of GDP) in Dominica and Expenditure(as % of GDP) in Saudi Arabia?
Your answer should be compact. 0.61. In the year 2000, what is the difference between the Expenditure(as % of GDP) of Liberia and Expenditure(as % of GDP) of Saudi Arabia?
Make the answer very short. 1.68. In the year 2001, what is the difference between the Expenditure(as % of GDP) in Bulgaria and Expenditure(as % of GDP) in Dominica?
Give a very brief answer. 2.59. In the year 2001, what is the difference between the Expenditure(as % of GDP) in Bulgaria and Expenditure(as % of GDP) in Liberia?
Offer a terse response. 0.97. In the year 2001, what is the difference between the Expenditure(as % of GDP) of Bulgaria and Expenditure(as % of GDP) of Saudi Arabia?
Make the answer very short. 2.88. In the year 2001, what is the difference between the Expenditure(as % of GDP) in Dominica and Expenditure(as % of GDP) in Liberia?
Give a very brief answer. -1.62. In the year 2001, what is the difference between the Expenditure(as % of GDP) in Dominica and Expenditure(as % of GDP) in Saudi Arabia?
Give a very brief answer. 0.3. In the year 2001, what is the difference between the Expenditure(as % of GDP) of Liberia and Expenditure(as % of GDP) of Saudi Arabia?
Provide a short and direct response. 1.92. In the year 2002, what is the difference between the Expenditure(as % of GDP) of Bulgaria and Expenditure(as % of GDP) of Dominica?
Offer a terse response. 2.72. In the year 2002, what is the difference between the Expenditure(as % of GDP) in Bulgaria and Expenditure(as % of GDP) in Liberia?
Ensure brevity in your answer.  2.16. In the year 2002, what is the difference between the Expenditure(as % of GDP) in Bulgaria and Expenditure(as % of GDP) in Saudi Arabia?
Provide a short and direct response. 3.31. In the year 2002, what is the difference between the Expenditure(as % of GDP) in Dominica and Expenditure(as % of GDP) in Liberia?
Provide a succinct answer. -0.56. In the year 2002, what is the difference between the Expenditure(as % of GDP) of Dominica and Expenditure(as % of GDP) of Saudi Arabia?
Ensure brevity in your answer.  0.59. In the year 2002, what is the difference between the Expenditure(as % of GDP) in Liberia and Expenditure(as % of GDP) in Saudi Arabia?
Offer a terse response. 1.15. In the year 2003, what is the difference between the Expenditure(as % of GDP) of Bulgaria and Expenditure(as % of GDP) of Dominica?
Your response must be concise. 2.87. In the year 2003, what is the difference between the Expenditure(as % of GDP) in Bulgaria and Expenditure(as % of GDP) in Liberia?
Give a very brief answer. 4.14. In the year 2003, what is the difference between the Expenditure(as % of GDP) of Bulgaria and Expenditure(as % of GDP) of Saudi Arabia?
Your answer should be compact. 3.58. In the year 2003, what is the difference between the Expenditure(as % of GDP) in Dominica and Expenditure(as % of GDP) in Liberia?
Ensure brevity in your answer.  1.28. In the year 2003, what is the difference between the Expenditure(as % of GDP) of Dominica and Expenditure(as % of GDP) of Saudi Arabia?
Ensure brevity in your answer.  0.71. In the year 2003, what is the difference between the Expenditure(as % of GDP) of Liberia and Expenditure(as % of GDP) of Saudi Arabia?
Give a very brief answer. -0.56. In the year 2004, what is the difference between the Expenditure(as % of GDP) of Bulgaria and Expenditure(as % of GDP) of Dominica?
Your answer should be compact. 2.9. In the year 2004, what is the difference between the Expenditure(as % of GDP) of Bulgaria and Expenditure(as % of GDP) of Liberia?
Provide a short and direct response. -1.46. In the year 2004, what is the difference between the Expenditure(as % of GDP) of Bulgaria and Expenditure(as % of GDP) of Saudi Arabia?
Keep it short and to the point. 3.62. In the year 2004, what is the difference between the Expenditure(as % of GDP) in Dominica and Expenditure(as % of GDP) in Liberia?
Keep it short and to the point. -4.36. In the year 2004, what is the difference between the Expenditure(as % of GDP) of Dominica and Expenditure(as % of GDP) of Saudi Arabia?
Ensure brevity in your answer.  0.72. In the year 2004, what is the difference between the Expenditure(as % of GDP) in Liberia and Expenditure(as % of GDP) in Saudi Arabia?
Provide a short and direct response. 5.08. In the year 2005, what is the difference between the Expenditure(as % of GDP) of Bulgaria and Expenditure(as % of GDP) of Dominica?
Provide a succinct answer. 2.6. In the year 2005, what is the difference between the Expenditure(as % of GDP) in Bulgaria and Expenditure(as % of GDP) in Liberia?
Provide a short and direct response. -0.73. In the year 2005, what is the difference between the Expenditure(as % of GDP) of Bulgaria and Expenditure(as % of GDP) of Saudi Arabia?
Ensure brevity in your answer.  3.76. In the year 2005, what is the difference between the Expenditure(as % of GDP) of Dominica and Expenditure(as % of GDP) of Liberia?
Your response must be concise. -3.33. In the year 2005, what is the difference between the Expenditure(as % of GDP) in Dominica and Expenditure(as % of GDP) in Saudi Arabia?
Make the answer very short. 1.16. In the year 2005, what is the difference between the Expenditure(as % of GDP) in Liberia and Expenditure(as % of GDP) in Saudi Arabia?
Ensure brevity in your answer.  4.49. What is the ratio of the Expenditure(as % of GDP) in Bulgaria in 1999 to that in 2000?
Make the answer very short. 0.97. What is the ratio of the Expenditure(as % of GDP) in Dominica in 1999 to that in 2000?
Your answer should be compact. 1.19. What is the ratio of the Expenditure(as % of GDP) of Liberia in 1999 to that in 2000?
Your answer should be compact. 1.02. What is the ratio of the Expenditure(as % of GDP) of Saudi Arabia in 1999 to that in 2000?
Keep it short and to the point. 0.97. What is the ratio of the Expenditure(as % of GDP) of Bulgaria in 1999 to that in 2001?
Make the answer very short. 0.81. What is the ratio of the Expenditure(as % of GDP) of Dominica in 1999 to that in 2001?
Provide a succinct answer. 1.21. What is the ratio of the Expenditure(as % of GDP) of Liberia in 1999 to that in 2001?
Give a very brief answer. 0.94. What is the ratio of the Expenditure(as % of GDP) of Saudi Arabia in 1999 to that in 2001?
Give a very brief answer. 0.91. What is the ratio of the Expenditure(as % of GDP) of Bulgaria in 1999 to that in 2002?
Your response must be concise. 0.79. What is the ratio of the Expenditure(as % of GDP) in Dominica in 1999 to that in 2002?
Your answer should be very brief. 1.19. What is the ratio of the Expenditure(as % of GDP) of Liberia in 1999 to that in 2002?
Your response must be concise. 1.11. What is the ratio of the Expenditure(as % of GDP) of Saudi Arabia in 1999 to that in 2002?
Your answer should be very brief. 0.96. What is the ratio of the Expenditure(as % of GDP) of Bulgaria in 1999 to that in 2003?
Make the answer very short. 0.79. What is the ratio of the Expenditure(as % of GDP) of Dominica in 1999 to that in 2003?
Provide a succinct answer. 1.23. What is the ratio of the Expenditure(as % of GDP) in Liberia in 1999 to that in 2003?
Provide a short and direct response. 1.76. What is the ratio of the Expenditure(as % of GDP) in Saudi Arabia in 1999 to that in 2003?
Offer a terse response. 1.02. What is the ratio of the Expenditure(as % of GDP) of Bulgaria in 1999 to that in 2004?
Ensure brevity in your answer.  0.82. What is the ratio of the Expenditure(as % of GDP) of Dominica in 1999 to that in 2004?
Your answer should be very brief. 1.31. What is the ratio of the Expenditure(as % of GDP) of Liberia in 1999 to that in 2004?
Give a very brief answer. 0.69. What is the ratio of the Expenditure(as % of GDP) of Saudi Arabia in 1999 to that in 2004?
Your response must be concise. 1.11. What is the ratio of the Expenditure(as % of GDP) of Bulgaria in 1999 to that in 2005?
Ensure brevity in your answer.  0.82. What is the ratio of the Expenditure(as % of GDP) of Dominica in 1999 to that in 2005?
Offer a terse response. 1.23. What is the ratio of the Expenditure(as % of GDP) in Liberia in 1999 to that in 2005?
Keep it short and to the point. 0.75. What is the ratio of the Expenditure(as % of GDP) in Saudi Arabia in 1999 to that in 2005?
Give a very brief answer. 1.16. What is the ratio of the Expenditure(as % of GDP) in Bulgaria in 2000 to that in 2001?
Keep it short and to the point. 0.84. What is the ratio of the Expenditure(as % of GDP) in Dominica in 2000 to that in 2001?
Your answer should be very brief. 1.01. What is the ratio of the Expenditure(as % of GDP) in Liberia in 2000 to that in 2001?
Your response must be concise. 0.92. What is the ratio of the Expenditure(as % of GDP) in Saudi Arabia in 2000 to that in 2001?
Your answer should be compact. 0.94. What is the ratio of the Expenditure(as % of GDP) of Bulgaria in 2000 to that in 2002?
Offer a very short reply. 0.82. What is the ratio of the Expenditure(as % of GDP) in Dominica in 2000 to that in 2002?
Provide a short and direct response. 0.99. What is the ratio of the Expenditure(as % of GDP) of Liberia in 2000 to that in 2002?
Make the answer very short. 1.09. What is the ratio of the Expenditure(as % of GDP) of Bulgaria in 2000 to that in 2003?
Provide a succinct answer. 0.82. What is the ratio of the Expenditure(as % of GDP) of Dominica in 2000 to that in 2003?
Your response must be concise. 1.03. What is the ratio of the Expenditure(as % of GDP) in Liberia in 2000 to that in 2003?
Your response must be concise. 1.72. What is the ratio of the Expenditure(as % of GDP) in Saudi Arabia in 2000 to that in 2003?
Your answer should be compact. 1.06. What is the ratio of the Expenditure(as % of GDP) of Bulgaria in 2000 to that in 2004?
Give a very brief answer. 0.85. What is the ratio of the Expenditure(as % of GDP) of Dominica in 2000 to that in 2004?
Ensure brevity in your answer.  1.1. What is the ratio of the Expenditure(as % of GDP) of Liberia in 2000 to that in 2004?
Keep it short and to the point. 0.67. What is the ratio of the Expenditure(as % of GDP) of Saudi Arabia in 2000 to that in 2004?
Provide a succinct answer. 1.15. What is the ratio of the Expenditure(as % of GDP) in Bulgaria in 2000 to that in 2005?
Provide a succinct answer. 0.85. What is the ratio of the Expenditure(as % of GDP) in Dominica in 2000 to that in 2005?
Provide a short and direct response. 1.03. What is the ratio of the Expenditure(as % of GDP) in Liberia in 2000 to that in 2005?
Offer a terse response. 0.74. What is the ratio of the Expenditure(as % of GDP) of Saudi Arabia in 2000 to that in 2005?
Keep it short and to the point. 1.19. What is the ratio of the Expenditure(as % of GDP) in Bulgaria in 2001 to that in 2002?
Offer a terse response. 0.97. What is the ratio of the Expenditure(as % of GDP) of Dominica in 2001 to that in 2002?
Give a very brief answer. 0.98. What is the ratio of the Expenditure(as % of GDP) of Liberia in 2001 to that in 2002?
Offer a terse response. 1.18. What is the ratio of the Expenditure(as % of GDP) of Saudi Arabia in 2001 to that in 2002?
Make the answer very short. 1.05. What is the ratio of the Expenditure(as % of GDP) of Bulgaria in 2001 to that in 2003?
Your answer should be compact. 0.97. What is the ratio of the Expenditure(as % of GDP) in Liberia in 2001 to that in 2003?
Ensure brevity in your answer.  1.86. What is the ratio of the Expenditure(as % of GDP) in Saudi Arabia in 2001 to that in 2003?
Make the answer very short. 1.12. What is the ratio of the Expenditure(as % of GDP) of Bulgaria in 2001 to that in 2004?
Keep it short and to the point. 1.01. What is the ratio of the Expenditure(as % of GDP) in Dominica in 2001 to that in 2004?
Give a very brief answer. 1.08. What is the ratio of the Expenditure(as % of GDP) in Liberia in 2001 to that in 2004?
Keep it short and to the point. 0.73. What is the ratio of the Expenditure(as % of GDP) in Saudi Arabia in 2001 to that in 2004?
Give a very brief answer. 1.21. What is the ratio of the Expenditure(as % of GDP) in Bulgaria in 2001 to that in 2005?
Offer a very short reply. 1.01. What is the ratio of the Expenditure(as % of GDP) in Dominica in 2001 to that in 2005?
Give a very brief answer. 1.02. What is the ratio of the Expenditure(as % of GDP) in Liberia in 2001 to that in 2005?
Ensure brevity in your answer.  0.8. What is the ratio of the Expenditure(as % of GDP) of Saudi Arabia in 2001 to that in 2005?
Your answer should be compact. 1.27. What is the ratio of the Expenditure(as % of GDP) in Bulgaria in 2002 to that in 2003?
Offer a very short reply. 1. What is the ratio of the Expenditure(as % of GDP) in Dominica in 2002 to that in 2003?
Offer a terse response. 1.03. What is the ratio of the Expenditure(as % of GDP) of Liberia in 2002 to that in 2003?
Ensure brevity in your answer.  1.58. What is the ratio of the Expenditure(as % of GDP) of Saudi Arabia in 2002 to that in 2003?
Your answer should be very brief. 1.07. What is the ratio of the Expenditure(as % of GDP) in Bulgaria in 2002 to that in 2004?
Make the answer very short. 1.04. What is the ratio of the Expenditure(as % of GDP) of Dominica in 2002 to that in 2004?
Provide a short and direct response. 1.1. What is the ratio of the Expenditure(as % of GDP) in Liberia in 2002 to that in 2004?
Make the answer very short. 0.62. What is the ratio of the Expenditure(as % of GDP) of Saudi Arabia in 2002 to that in 2004?
Your answer should be compact. 1.16. What is the ratio of the Expenditure(as % of GDP) in Bulgaria in 2002 to that in 2005?
Provide a short and direct response. 1.04. What is the ratio of the Expenditure(as % of GDP) of Dominica in 2002 to that in 2005?
Keep it short and to the point. 1.03. What is the ratio of the Expenditure(as % of GDP) of Liberia in 2002 to that in 2005?
Ensure brevity in your answer.  0.68. What is the ratio of the Expenditure(as % of GDP) in Saudi Arabia in 2002 to that in 2005?
Make the answer very short. 1.2. What is the ratio of the Expenditure(as % of GDP) in Bulgaria in 2003 to that in 2004?
Ensure brevity in your answer.  1.04. What is the ratio of the Expenditure(as % of GDP) in Dominica in 2003 to that in 2004?
Ensure brevity in your answer.  1.07. What is the ratio of the Expenditure(as % of GDP) in Liberia in 2003 to that in 2004?
Ensure brevity in your answer.  0.39. What is the ratio of the Expenditure(as % of GDP) in Saudi Arabia in 2003 to that in 2004?
Provide a succinct answer. 1.08. What is the ratio of the Expenditure(as % of GDP) of Bulgaria in 2003 to that in 2005?
Offer a very short reply. 1.04. What is the ratio of the Expenditure(as % of GDP) in Dominica in 2003 to that in 2005?
Provide a succinct answer. 1. What is the ratio of the Expenditure(as % of GDP) in Liberia in 2003 to that in 2005?
Provide a succinct answer. 0.43. What is the ratio of the Expenditure(as % of GDP) of Saudi Arabia in 2003 to that in 2005?
Offer a terse response. 1.13. What is the ratio of the Expenditure(as % of GDP) in Bulgaria in 2004 to that in 2005?
Your response must be concise. 1. What is the ratio of the Expenditure(as % of GDP) of Dominica in 2004 to that in 2005?
Your response must be concise. 0.94. What is the ratio of the Expenditure(as % of GDP) of Liberia in 2004 to that in 2005?
Your answer should be very brief. 1.09. What is the ratio of the Expenditure(as % of GDP) in Saudi Arabia in 2004 to that in 2005?
Provide a succinct answer. 1.04. What is the difference between the highest and the second highest Expenditure(as % of GDP) in Bulgaria?
Provide a short and direct response. 0. What is the difference between the highest and the second highest Expenditure(as % of GDP) in Dominica?
Keep it short and to the point. 0.91. What is the difference between the highest and the second highest Expenditure(as % of GDP) of Liberia?
Offer a terse response. 0.74. What is the difference between the highest and the second highest Expenditure(as % of GDP) of Saudi Arabia?
Provide a short and direct response. 0.22. What is the difference between the highest and the lowest Expenditure(as % of GDP) in Bulgaria?
Provide a succinct answer. 1.61. What is the difference between the highest and the lowest Expenditure(as % of GDP) of Dominica?
Make the answer very short. 1.37. What is the difference between the highest and the lowest Expenditure(as % of GDP) of Liberia?
Offer a very short reply. 5.34. What is the difference between the highest and the lowest Expenditure(as % of GDP) of Saudi Arabia?
Your answer should be compact. 0.94. 